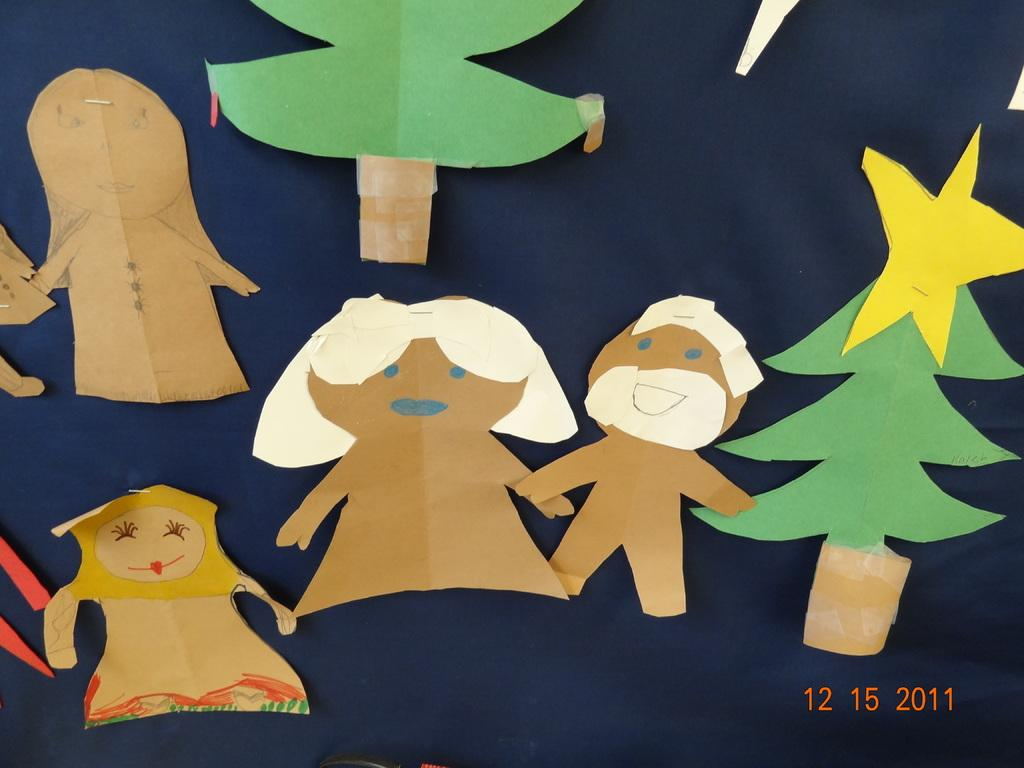What type of handicraft is visible in the image? There is a paper handicraft in the image. How is the paper handicraft attached to the person's cloth? The paper handicraft is stapled to a person's cloth. What is the main decoration in the image? There is a Christmas tree in the image. What color is the star on the Christmas tree? There is a yellow star in the image. What type of tin can be seen hanging from the person's ear in the image? There is no tin or earrings visible in the image; it only features a paper handicraft stapled to a person's cloth, a Christmas tree, and a yellow star. 